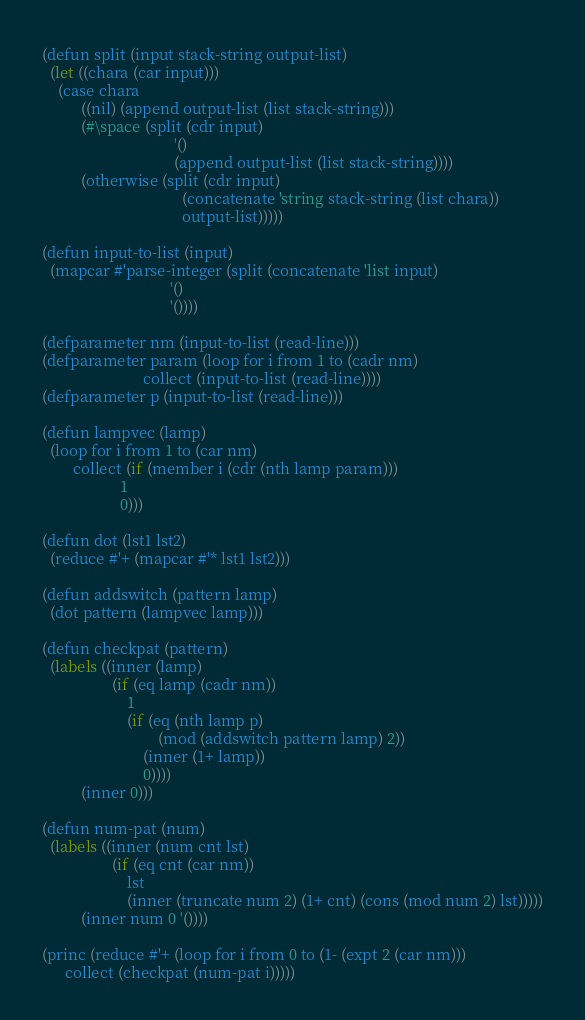<code> <loc_0><loc_0><loc_500><loc_500><_Lisp_>(defun split (input stack-string output-list)
  (let ((chara (car input)))
    (case chara
          ((nil) (append output-list (list stack-string)))
          (#\space (split (cdr input)
                                  '()
                                  (append output-list (list stack-string))))
          (otherwise (split (cdr input)
                                    (concatenate 'string stack-string (list chara))
                                    output-list)))))

(defun input-to-list (input)
  (mapcar #'parse-integer (split (concatenate 'list input)
                                 '()
                                 '())))

(defparameter nm (input-to-list (read-line)))
(defparameter param (loop for i from 1 to (cadr nm)
                          collect (input-to-list (read-line))))
(defparameter p (input-to-list (read-line)))

(defun lampvec (lamp)
  (loop for i from 1 to (car nm)
        collect (if (member i (cdr (nth lamp param)))
                    1
                    0)))

(defun dot (lst1 lst2)
  (reduce #'+ (mapcar #'* lst1 lst2)))

(defun addswitch (pattern lamp)
  (dot pattern (lampvec lamp)))

(defun checkpat (pattern)
  (labels ((inner (lamp)
                  (if (eq lamp (cadr nm))
                      1
                      (if (eq (nth lamp p)
                              (mod (addswitch pattern lamp) 2))
                          (inner (1+ lamp))
                          0))))
          (inner 0)))

(defun num-pat (num)
  (labels ((inner (num cnt lst)
                  (if (eq cnt (car nm))
                      lst
                      (inner (truncate num 2) (1+ cnt) (cons (mod num 2) lst)))))
          (inner num 0 '())))

(princ (reduce #'+ (loop for i from 0 to (1- (expt 2 (car nm)))
      collect (checkpat (num-pat i)))))</code> 